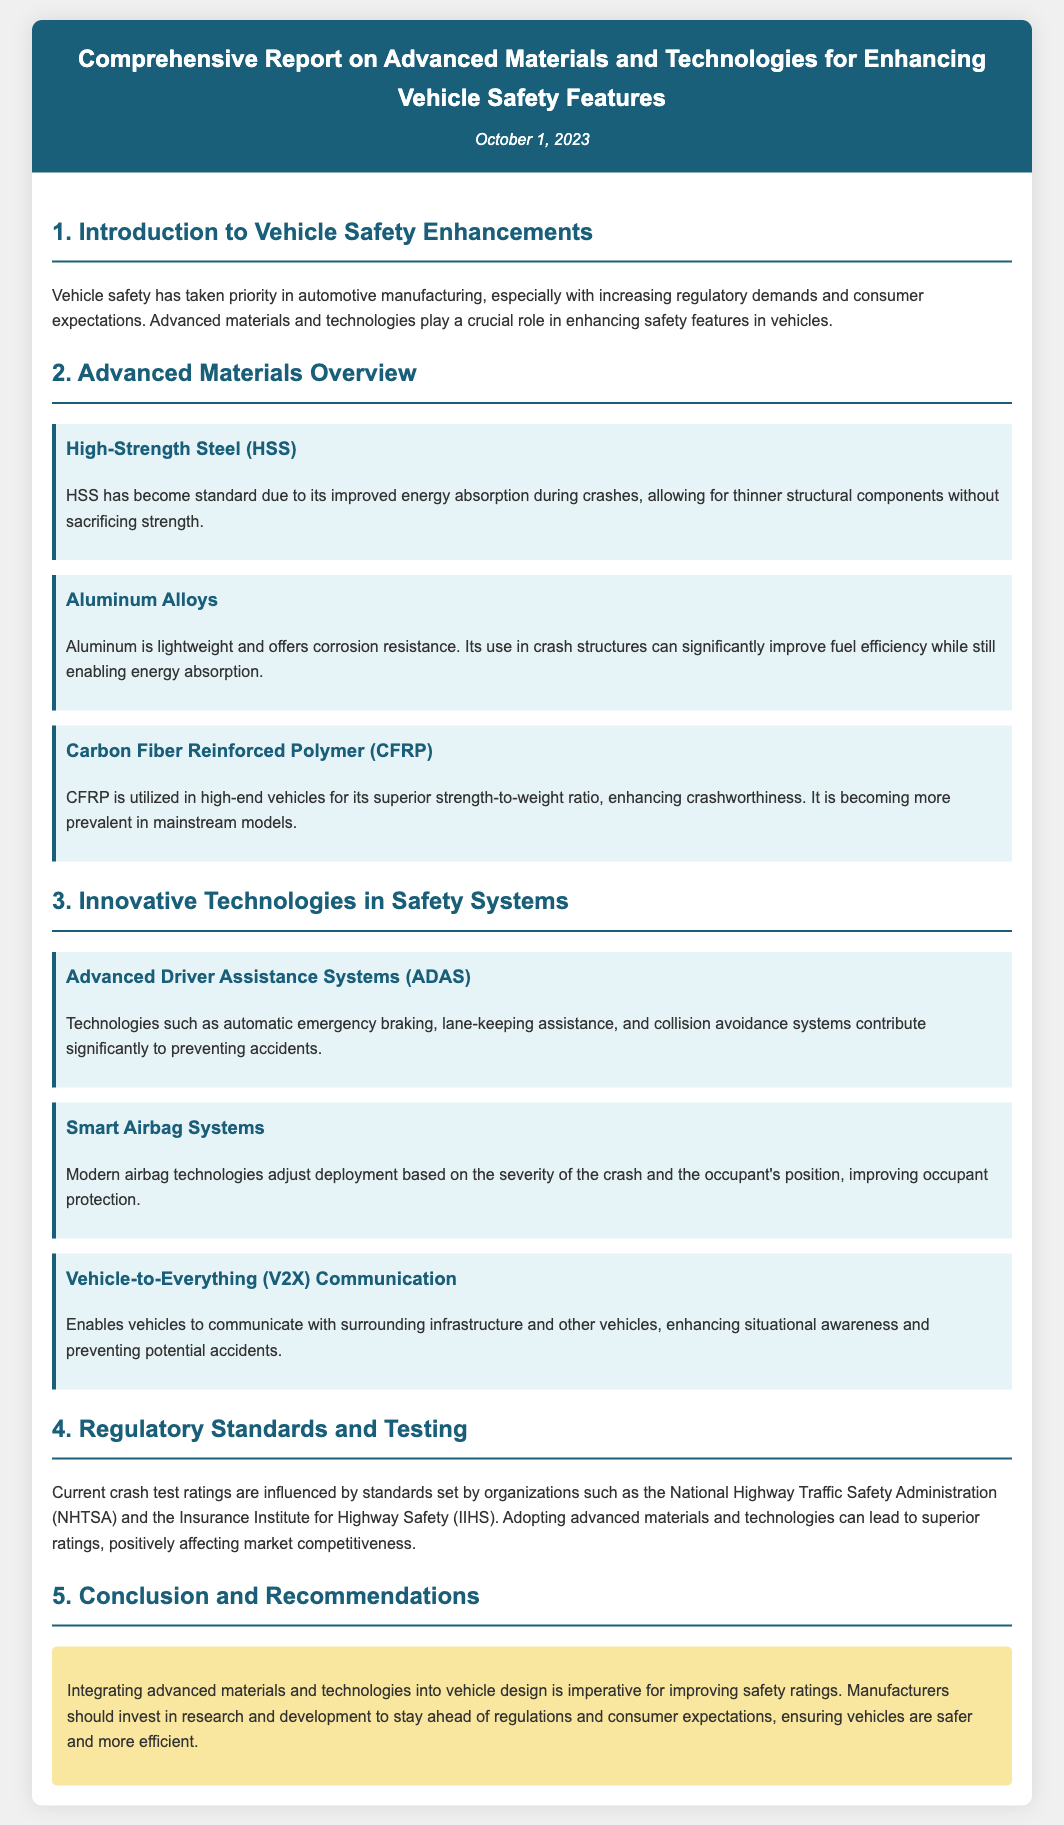what is the title of the document? The title is listed at the top of the document, presenting the report's focus on materials and technologies for vehicle safety.
Answer: Comprehensive Report on Advanced Materials and Technologies for Enhancing Vehicle Safety Features when was the report published? The publication date is mentioned in the header section of the document, providing the date the report was finalized.
Answer: October 1, 2023 name one advanced material mentioned in the report. The document details specific advanced materials that enhance vehicle safety in the "Advanced Materials Overview" section.
Answer: High-Strength Steel (HSS) what role does CFRP play in vehicle safety? The report explains that CFRP enhances crashworthiness through its superior strength-to-weight ratio, making it significant for safer vehicle designs.
Answer: Enhances crashworthiness list one innovative technology discussed in the report. The document outlines several technologies within the "Innovative Technologies in Safety Systems" section that contribute to vehicle safety.
Answer: Advanced Driver Assistance Systems (ADAS) how do smart airbag systems improve safety? The document specifies that smart airbag technologies adjust their deployment based on certain conditions, thus offering better protection for occupants.
Answer: Adjust deployment based on crash severity which organization sets current crash test standards? The document refers to key organizations that influence crash test ratings, outlining their role in vehicle safety protocols.
Answer: National Highway Traffic Safety Administration (NHTSA) what is recommended for manufacturers at the conclusion of the report? The conclusion advises manufacturers on steps to enhance vehicle safety and competitiveness in the market.
Answer: Invest in research and development what is the focus of the introduction section? The introduction sets the stage for the report by emphasizing the importance of safety in vehicle manufacturing amidst regulatory demands and consumer expectations.
Answer: Vehicle safety enhancements 